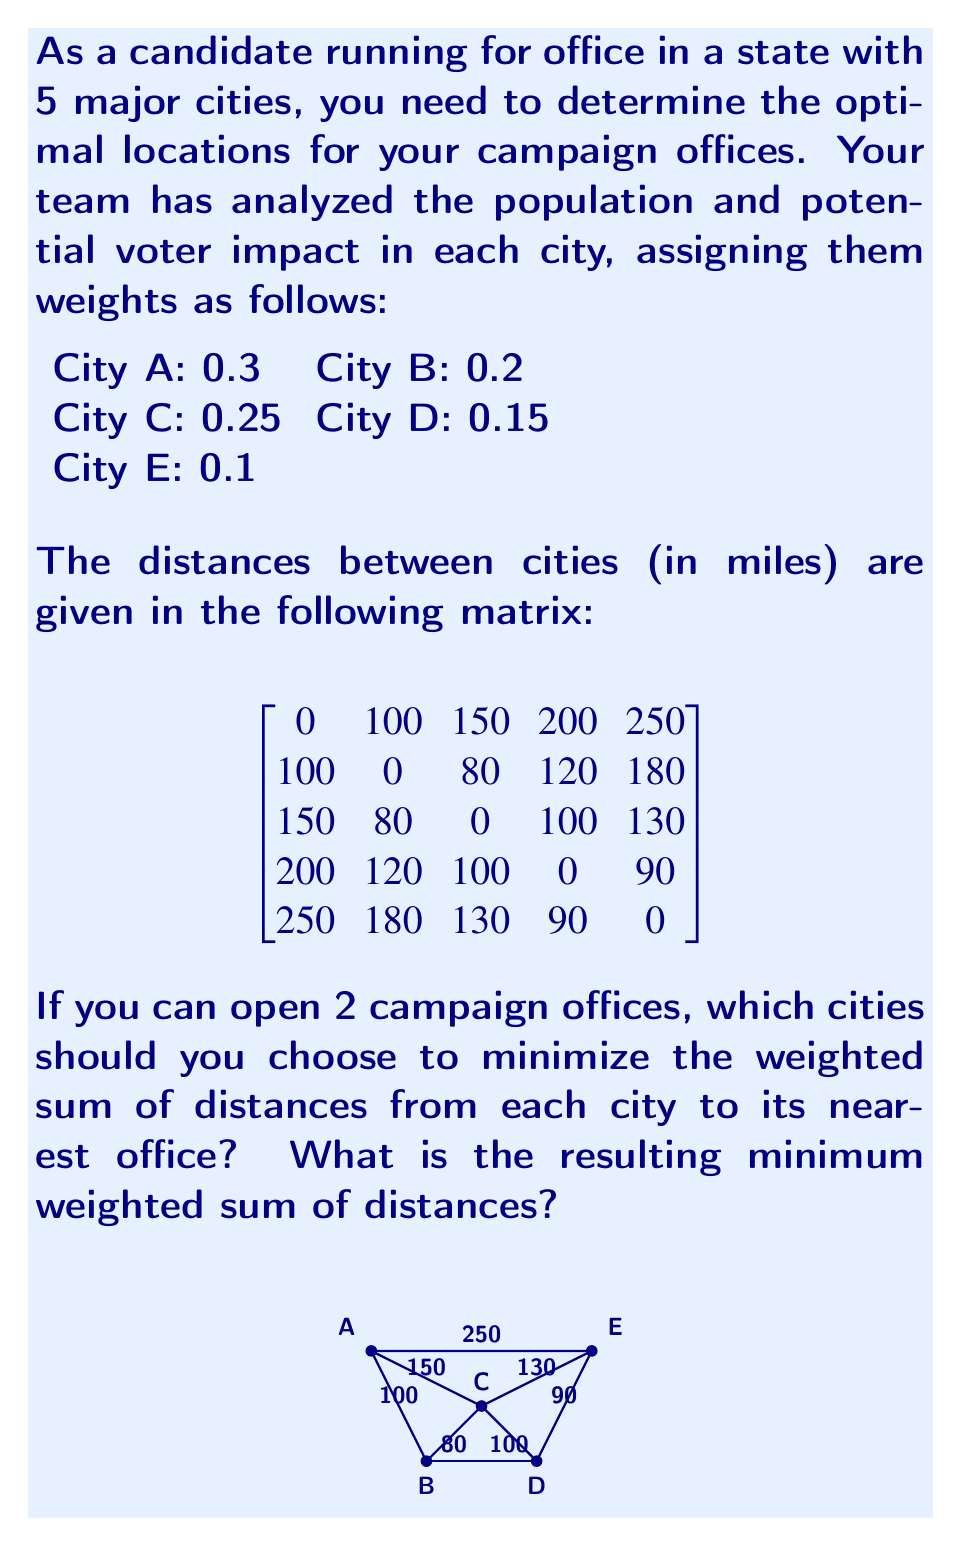Can you answer this question? To solve this problem, we'll use the p-median facility location model. Here are the steps:

1) First, we need to calculate the weighted distance for each pair of cities. We multiply each distance by the weight of the destination city.

2) We create a new matrix of weighted distances:

$$
\begin{bmatrix}
0 & 20 & 37.5 & 30 & 25 \\
30 & 0 & 20 & 18 & 18 \\
45 & 16 & 0 & 15 & 13 \\
60 & 24 & 25 & 0 & 9 \\
75 & 36 & 32.5 & 13.5 & 0
\end{bmatrix}
$$

3) Now, we need to consider all possible combinations of 2 cities out of 5. There are $\binom{5}{2} = 10$ such combinations.

4) For each combination, we calculate the total weighted sum of distances by assigning each city to its nearest office and summing the weighted distances.

5) Here are the calculations for each combination:

   A,B: 0 + 0 + 20 + 18 + 25 = 63
   A,C: 0 + 16 + 0 + 15 + 25 = 56
   A,D: 0 + 18 + 15 + 0 + 25 = 58
   A,E: 0 + 18 + 13 + 9 + 0 = 40
   B,C: 20 + 0 + 0 + 15 + 13 = 48
   B,D: 20 + 0 + 15 + 0 + 9 = 44
   B,E: 20 + 0 + 13 + 9 + 0 = 42
   C,D: 37.5 + 16 + 0 + 0 + 9 = 62.5
   C,E: 25 + 16 + 0 + 9 + 0 = 50
   D,E: 25 + 18 + 13 + 0 + 0 = 56

6) The minimum weighted sum of distances is 40, corresponding to placing offices in cities A and E.
Answer: Cities A and E; 40 